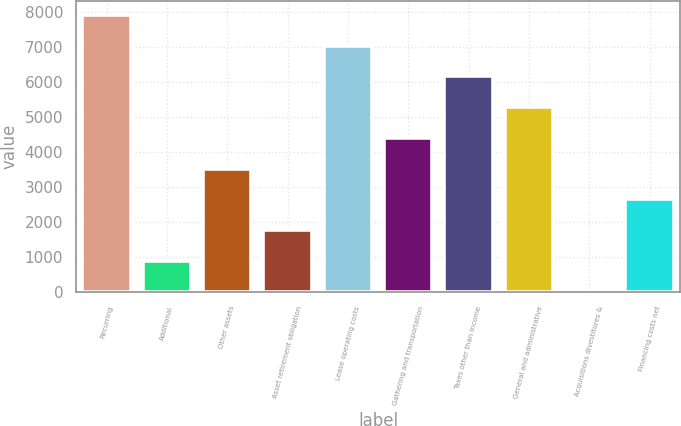<chart> <loc_0><loc_0><loc_500><loc_500><bar_chart><fcel>Recurring<fcel>Additional<fcel>Other assets<fcel>Asset retirement obligation<fcel>Lease operating costs<fcel>Gathering and transportation<fcel>Taxes other than income<fcel>General and administrative<fcel>Acquisitions divestitures &<fcel>Financing costs net<nl><fcel>7917.5<fcel>897.5<fcel>3530<fcel>1775<fcel>7040<fcel>4407.5<fcel>6162.5<fcel>5285<fcel>20<fcel>2652.5<nl></chart> 